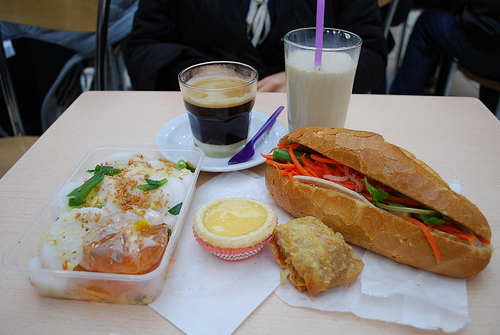<image>
Is the glass on the table? Yes. Looking at the image, I can see the glass is positioned on top of the table, with the table providing support. Is the beer next to the milk? Yes. The beer is positioned adjacent to the milk, located nearby in the same general area. Is there a paper in front of the food? No. The paper is not in front of the food. The spatial positioning shows a different relationship between these objects. 